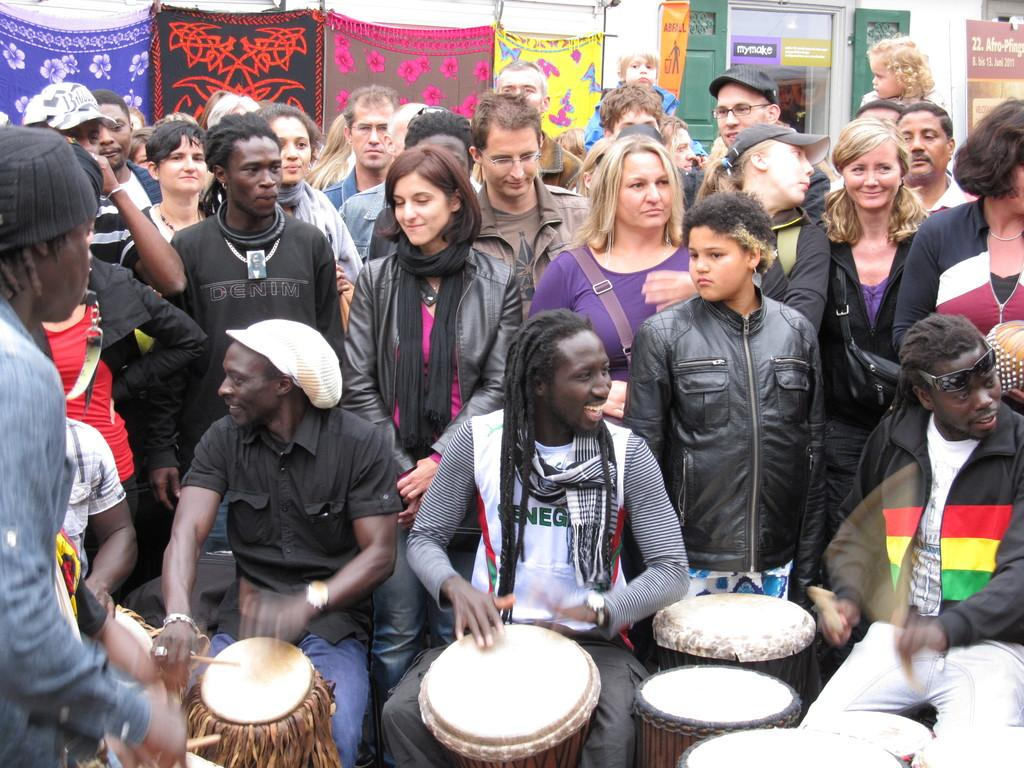How many people are in the image? There is a group of people in the image. What are two of the people doing in the image? Two persons are playing drums in the image. Reasoning: Let' Let's think step by step in order to produce the conversation. We start by identifying the main subject of the image, which is the group of people. Then, we focus on the specific activity of two persons within the group, who are playing drums. Each question is designed to elicit a specific detail about the image that is known from the provided facts. Absurd Question/Answer: What is the opinion of the vessel in the image? There is no vessel present in the image, so it cannot determine its opinion. 